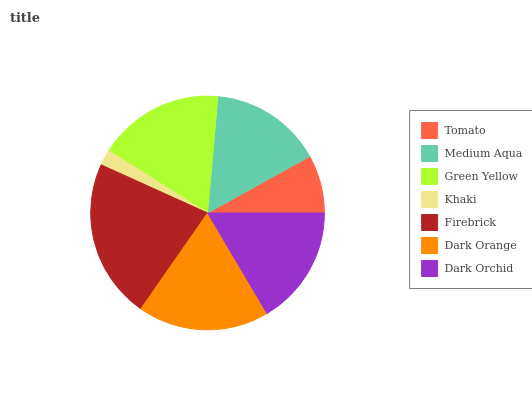Is Khaki the minimum?
Answer yes or no. Yes. Is Firebrick the maximum?
Answer yes or no. Yes. Is Medium Aqua the minimum?
Answer yes or no. No. Is Medium Aqua the maximum?
Answer yes or no. No. Is Medium Aqua greater than Tomato?
Answer yes or no. Yes. Is Tomato less than Medium Aqua?
Answer yes or no. Yes. Is Tomato greater than Medium Aqua?
Answer yes or no. No. Is Medium Aqua less than Tomato?
Answer yes or no. No. Is Dark Orchid the high median?
Answer yes or no. Yes. Is Dark Orchid the low median?
Answer yes or no. Yes. Is Dark Orange the high median?
Answer yes or no. No. Is Medium Aqua the low median?
Answer yes or no. No. 